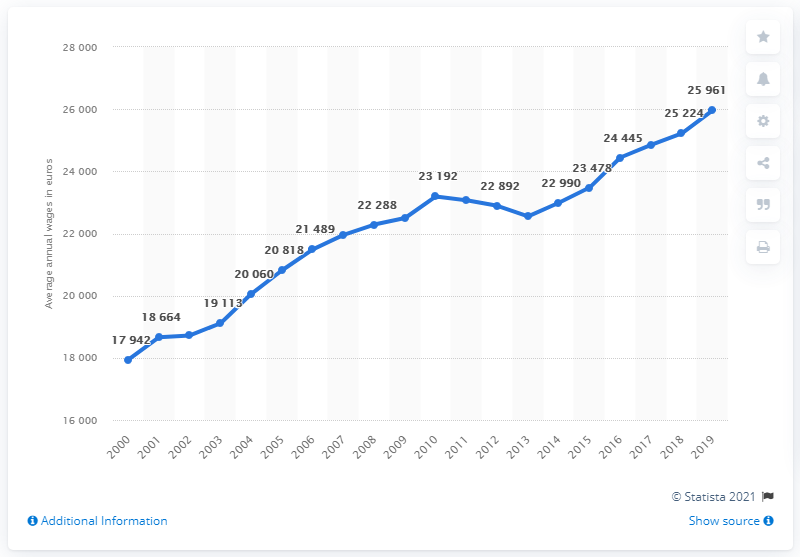List a handful of essential elements in this visual. In 2019, the average annual wage in Slovenia was 25,961 euros. 